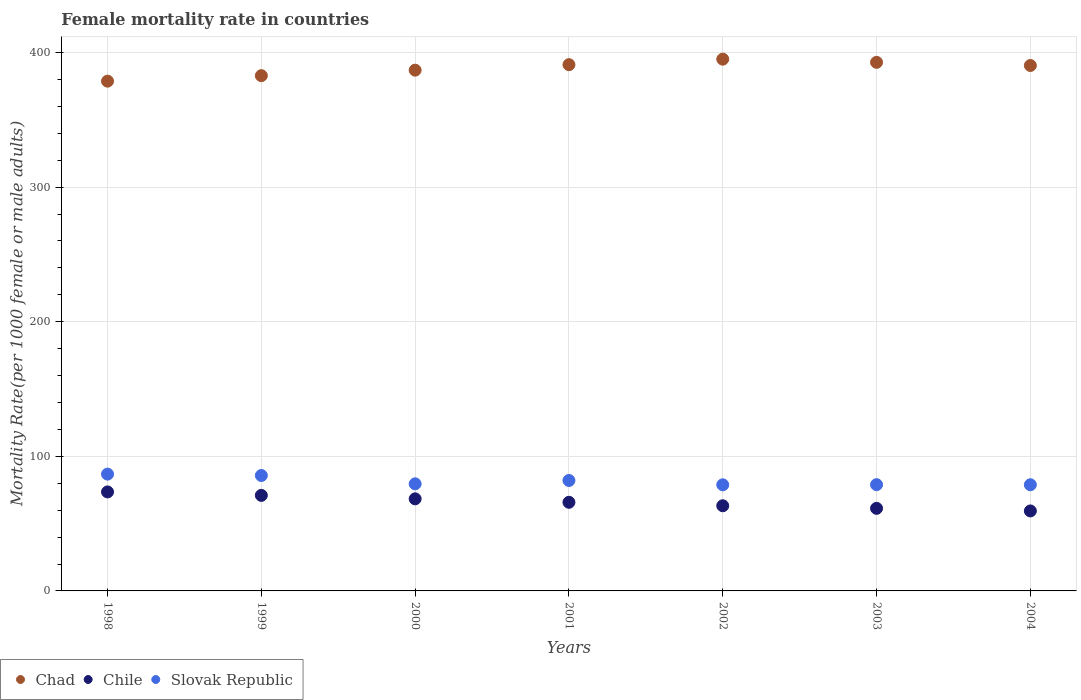How many different coloured dotlines are there?
Your response must be concise. 3. Is the number of dotlines equal to the number of legend labels?
Provide a short and direct response. Yes. What is the female mortality rate in Slovak Republic in 2001?
Offer a terse response. 82.06. Across all years, what is the maximum female mortality rate in Chad?
Make the answer very short. 395.1. Across all years, what is the minimum female mortality rate in Slovak Republic?
Offer a very short reply. 78.84. In which year was the female mortality rate in Chad minimum?
Provide a succinct answer. 1998. What is the total female mortality rate in Chad in the graph?
Your answer should be compact. 2717.83. What is the difference between the female mortality rate in Chad in 2000 and that in 2004?
Make the answer very short. -3.47. What is the difference between the female mortality rate in Chad in 2004 and the female mortality rate in Chile in 1999?
Your response must be concise. 319.42. What is the average female mortality rate in Chile per year?
Your response must be concise. 66.12. In the year 2002, what is the difference between the female mortality rate in Chile and female mortality rate in Slovak Republic?
Provide a succinct answer. -15.56. What is the ratio of the female mortality rate in Slovak Republic in 2001 to that in 2004?
Give a very brief answer. 1.04. What is the difference between the highest and the second highest female mortality rate in Chad?
Offer a very short reply. 2.35. What is the difference between the highest and the lowest female mortality rate in Slovak Republic?
Provide a short and direct response. 7.94. In how many years, is the female mortality rate in Chad greater than the average female mortality rate in Chad taken over all years?
Provide a succinct answer. 4. Is it the case that in every year, the sum of the female mortality rate in Chad and female mortality rate in Chile  is greater than the female mortality rate in Slovak Republic?
Provide a succinct answer. Yes. Does the female mortality rate in Chad monotonically increase over the years?
Keep it short and to the point. No. Is the female mortality rate in Slovak Republic strictly less than the female mortality rate in Chile over the years?
Make the answer very short. No. Does the graph contain any zero values?
Offer a terse response. No. How many legend labels are there?
Offer a very short reply. 3. How are the legend labels stacked?
Give a very brief answer. Horizontal. What is the title of the graph?
Make the answer very short. Female mortality rate in countries. Does "Turkey" appear as one of the legend labels in the graph?
Your answer should be very brief. No. What is the label or title of the X-axis?
Give a very brief answer. Years. What is the label or title of the Y-axis?
Keep it short and to the point. Mortality Rate(per 1000 female or male adults). What is the Mortality Rate(per 1000 female or male adults) in Chad in 1998?
Provide a succinct answer. 378.76. What is the Mortality Rate(per 1000 female or male adults) in Chile in 1998?
Ensure brevity in your answer.  73.56. What is the Mortality Rate(per 1000 female or male adults) in Slovak Republic in 1998?
Your response must be concise. 86.78. What is the Mortality Rate(per 1000 female or male adults) in Chad in 1999?
Your response must be concise. 382.85. What is the Mortality Rate(per 1000 female or male adults) in Chile in 1999?
Give a very brief answer. 70.99. What is the Mortality Rate(per 1000 female or male adults) in Slovak Republic in 1999?
Give a very brief answer. 85.76. What is the Mortality Rate(per 1000 female or male adults) in Chad in 2000?
Provide a succinct answer. 386.93. What is the Mortality Rate(per 1000 female or male adults) in Chile in 2000?
Give a very brief answer. 68.42. What is the Mortality Rate(per 1000 female or male adults) of Slovak Republic in 2000?
Offer a very short reply. 79.57. What is the Mortality Rate(per 1000 female or male adults) of Chad in 2001?
Give a very brief answer. 391.02. What is the Mortality Rate(per 1000 female or male adults) in Chile in 2001?
Provide a succinct answer. 65.85. What is the Mortality Rate(per 1000 female or male adults) in Slovak Republic in 2001?
Ensure brevity in your answer.  82.06. What is the Mortality Rate(per 1000 female or male adults) of Chad in 2002?
Offer a very short reply. 395.1. What is the Mortality Rate(per 1000 female or male adults) in Chile in 2002?
Provide a succinct answer. 63.28. What is the Mortality Rate(per 1000 female or male adults) of Slovak Republic in 2002?
Keep it short and to the point. 78.84. What is the Mortality Rate(per 1000 female or male adults) of Chad in 2003?
Provide a succinct answer. 392.75. What is the Mortality Rate(per 1000 female or male adults) of Chile in 2003?
Provide a short and direct response. 61.35. What is the Mortality Rate(per 1000 female or male adults) of Slovak Republic in 2003?
Give a very brief answer. 78.96. What is the Mortality Rate(per 1000 female or male adults) of Chad in 2004?
Offer a very short reply. 390.4. What is the Mortality Rate(per 1000 female or male adults) of Chile in 2004?
Give a very brief answer. 59.43. What is the Mortality Rate(per 1000 female or male adults) in Slovak Republic in 2004?
Give a very brief answer. 78.88. Across all years, what is the maximum Mortality Rate(per 1000 female or male adults) in Chad?
Your answer should be very brief. 395.1. Across all years, what is the maximum Mortality Rate(per 1000 female or male adults) in Chile?
Provide a succinct answer. 73.56. Across all years, what is the maximum Mortality Rate(per 1000 female or male adults) of Slovak Republic?
Keep it short and to the point. 86.78. Across all years, what is the minimum Mortality Rate(per 1000 female or male adults) of Chad?
Give a very brief answer. 378.76. Across all years, what is the minimum Mortality Rate(per 1000 female or male adults) of Chile?
Offer a terse response. 59.43. Across all years, what is the minimum Mortality Rate(per 1000 female or male adults) in Slovak Republic?
Your answer should be very brief. 78.84. What is the total Mortality Rate(per 1000 female or male adults) of Chad in the graph?
Your answer should be compact. 2717.83. What is the total Mortality Rate(per 1000 female or male adults) of Chile in the graph?
Give a very brief answer. 462.87. What is the total Mortality Rate(per 1000 female or male adults) of Slovak Republic in the graph?
Keep it short and to the point. 570.85. What is the difference between the Mortality Rate(per 1000 female or male adults) in Chad in 1998 and that in 1999?
Your answer should be compact. -4.08. What is the difference between the Mortality Rate(per 1000 female or male adults) of Chile in 1998 and that in 1999?
Offer a very short reply. 2.57. What is the difference between the Mortality Rate(per 1000 female or male adults) of Chad in 1998 and that in 2000?
Make the answer very short. -8.17. What is the difference between the Mortality Rate(per 1000 female or male adults) of Chile in 1998 and that in 2000?
Provide a succinct answer. 5.14. What is the difference between the Mortality Rate(per 1000 female or male adults) of Slovak Republic in 1998 and that in 2000?
Ensure brevity in your answer.  7.21. What is the difference between the Mortality Rate(per 1000 female or male adults) in Chad in 1998 and that in 2001?
Keep it short and to the point. -12.25. What is the difference between the Mortality Rate(per 1000 female or male adults) of Chile in 1998 and that in 2001?
Keep it short and to the point. 7.71. What is the difference between the Mortality Rate(per 1000 female or male adults) in Slovak Republic in 1998 and that in 2001?
Your answer should be compact. 4.71. What is the difference between the Mortality Rate(per 1000 female or male adults) of Chad in 1998 and that in 2002?
Your response must be concise. -16.34. What is the difference between the Mortality Rate(per 1000 female or male adults) in Chile in 1998 and that in 2002?
Keep it short and to the point. 10.28. What is the difference between the Mortality Rate(per 1000 female or male adults) of Slovak Republic in 1998 and that in 2002?
Keep it short and to the point. 7.94. What is the difference between the Mortality Rate(per 1000 female or male adults) in Chad in 1998 and that in 2003?
Give a very brief answer. -13.99. What is the difference between the Mortality Rate(per 1000 female or male adults) in Chile in 1998 and that in 2003?
Provide a succinct answer. 12.2. What is the difference between the Mortality Rate(per 1000 female or male adults) in Slovak Republic in 1998 and that in 2003?
Keep it short and to the point. 7.82. What is the difference between the Mortality Rate(per 1000 female or male adults) in Chad in 1998 and that in 2004?
Give a very brief answer. -11.64. What is the difference between the Mortality Rate(per 1000 female or male adults) of Chile in 1998 and that in 2004?
Give a very brief answer. 14.13. What is the difference between the Mortality Rate(per 1000 female or male adults) of Slovak Republic in 1998 and that in 2004?
Make the answer very short. 7.9. What is the difference between the Mortality Rate(per 1000 female or male adults) in Chad in 1999 and that in 2000?
Offer a very short reply. -4.08. What is the difference between the Mortality Rate(per 1000 female or male adults) in Chile in 1999 and that in 2000?
Your answer should be compact. 2.57. What is the difference between the Mortality Rate(per 1000 female or male adults) of Slovak Republic in 1999 and that in 2000?
Provide a short and direct response. 6.19. What is the difference between the Mortality Rate(per 1000 female or male adults) in Chad in 1999 and that in 2001?
Keep it short and to the point. -8.17. What is the difference between the Mortality Rate(per 1000 female or male adults) in Chile in 1999 and that in 2001?
Your answer should be very brief. 5.14. What is the difference between the Mortality Rate(per 1000 female or male adults) of Slovak Republic in 1999 and that in 2001?
Offer a very short reply. 3.69. What is the difference between the Mortality Rate(per 1000 female or male adults) in Chad in 1999 and that in 2002?
Offer a very short reply. -12.25. What is the difference between the Mortality Rate(per 1000 female or male adults) in Chile in 1999 and that in 2002?
Your response must be concise. 7.71. What is the difference between the Mortality Rate(per 1000 female or male adults) in Slovak Republic in 1999 and that in 2002?
Keep it short and to the point. 6.92. What is the difference between the Mortality Rate(per 1000 female or male adults) of Chad in 1999 and that in 2003?
Offer a very short reply. -9.9. What is the difference between the Mortality Rate(per 1000 female or male adults) of Chile in 1999 and that in 2003?
Keep it short and to the point. 9.63. What is the difference between the Mortality Rate(per 1000 female or male adults) of Slovak Republic in 1999 and that in 2003?
Offer a terse response. 6.8. What is the difference between the Mortality Rate(per 1000 female or male adults) in Chad in 1999 and that in 2004?
Ensure brevity in your answer.  -7.55. What is the difference between the Mortality Rate(per 1000 female or male adults) in Chile in 1999 and that in 2004?
Provide a succinct answer. 11.56. What is the difference between the Mortality Rate(per 1000 female or male adults) in Slovak Republic in 1999 and that in 2004?
Your response must be concise. 6.88. What is the difference between the Mortality Rate(per 1000 female or male adults) in Chad in 2000 and that in 2001?
Make the answer very short. -4.08. What is the difference between the Mortality Rate(per 1000 female or male adults) in Chile in 2000 and that in 2001?
Ensure brevity in your answer.  2.57. What is the difference between the Mortality Rate(per 1000 female or male adults) of Slovak Republic in 2000 and that in 2001?
Ensure brevity in your answer.  -2.5. What is the difference between the Mortality Rate(per 1000 female or male adults) of Chad in 2000 and that in 2002?
Your response must be concise. -8.17. What is the difference between the Mortality Rate(per 1000 female or male adults) of Chile in 2000 and that in 2002?
Offer a very short reply. 5.14. What is the difference between the Mortality Rate(per 1000 female or male adults) in Slovak Republic in 2000 and that in 2002?
Offer a very short reply. 0.73. What is the difference between the Mortality Rate(per 1000 female or male adults) in Chad in 2000 and that in 2003?
Your answer should be very brief. -5.82. What is the difference between the Mortality Rate(per 1000 female or male adults) of Chile in 2000 and that in 2003?
Ensure brevity in your answer.  7.06. What is the difference between the Mortality Rate(per 1000 female or male adults) in Slovak Republic in 2000 and that in 2003?
Ensure brevity in your answer.  0.61. What is the difference between the Mortality Rate(per 1000 female or male adults) in Chad in 2000 and that in 2004?
Give a very brief answer. -3.47. What is the difference between the Mortality Rate(per 1000 female or male adults) in Chile in 2000 and that in 2004?
Offer a very short reply. 8.99. What is the difference between the Mortality Rate(per 1000 female or male adults) in Slovak Republic in 2000 and that in 2004?
Your answer should be very brief. 0.69. What is the difference between the Mortality Rate(per 1000 female or male adults) in Chad in 2001 and that in 2002?
Your response must be concise. -4.08. What is the difference between the Mortality Rate(per 1000 female or male adults) of Chile in 2001 and that in 2002?
Your answer should be very brief. 2.57. What is the difference between the Mortality Rate(per 1000 female or male adults) of Slovak Republic in 2001 and that in 2002?
Provide a succinct answer. 3.23. What is the difference between the Mortality Rate(per 1000 female or male adults) in Chad in 2001 and that in 2003?
Ensure brevity in your answer.  -1.74. What is the difference between the Mortality Rate(per 1000 female or male adults) in Chile in 2001 and that in 2003?
Your response must be concise. 4.49. What is the difference between the Mortality Rate(per 1000 female or male adults) in Slovak Republic in 2001 and that in 2003?
Keep it short and to the point. 3.11. What is the difference between the Mortality Rate(per 1000 female or male adults) of Chad in 2001 and that in 2004?
Your response must be concise. 0.61. What is the difference between the Mortality Rate(per 1000 female or male adults) of Chile in 2001 and that in 2004?
Provide a succinct answer. 6.42. What is the difference between the Mortality Rate(per 1000 female or male adults) in Slovak Republic in 2001 and that in 2004?
Make the answer very short. 3.19. What is the difference between the Mortality Rate(per 1000 female or male adults) in Chad in 2002 and that in 2003?
Provide a short and direct response. 2.35. What is the difference between the Mortality Rate(per 1000 female or male adults) of Chile in 2002 and that in 2003?
Offer a very short reply. 1.92. What is the difference between the Mortality Rate(per 1000 female or male adults) in Slovak Republic in 2002 and that in 2003?
Keep it short and to the point. -0.12. What is the difference between the Mortality Rate(per 1000 female or male adults) of Chad in 2002 and that in 2004?
Your response must be concise. 4.7. What is the difference between the Mortality Rate(per 1000 female or male adults) of Chile in 2002 and that in 2004?
Keep it short and to the point. 3.85. What is the difference between the Mortality Rate(per 1000 female or male adults) of Slovak Republic in 2002 and that in 2004?
Provide a succinct answer. -0.04. What is the difference between the Mortality Rate(per 1000 female or male adults) in Chad in 2003 and that in 2004?
Make the answer very short. 2.35. What is the difference between the Mortality Rate(per 1000 female or male adults) in Chile in 2003 and that in 2004?
Offer a terse response. 1.93. What is the difference between the Mortality Rate(per 1000 female or male adults) of Slovak Republic in 2003 and that in 2004?
Give a very brief answer. 0.08. What is the difference between the Mortality Rate(per 1000 female or male adults) of Chad in 1998 and the Mortality Rate(per 1000 female or male adults) of Chile in 1999?
Keep it short and to the point. 307.78. What is the difference between the Mortality Rate(per 1000 female or male adults) of Chad in 1998 and the Mortality Rate(per 1000 female or male adults) of Slovak Republic in 1999?
Keep it short and to the point. 293.01. What is the difference between the Mortality Rate(per 1000 female or male adults) in Chile in 1998 and the Mortality Rate(per 1000 female or male adults) in Slovak Republic in 1999?
Your answer should be very brief. -12.2. What is the difference between the Mortality Rate(per 1000 female or male adults) of Chad in 1998 and the Mortality Rate(per 1000 female or male adults) of Chile in 2000?
Make the answer very short. 310.35. What is the difference between the Mortality Rate(per 1000 female or male adults) in Chad in 1998 and the Mortality Rate(per 1000 female or male adults) in Slovak Republic in 2000?
Keep it short and to the point. 299.2. What is the difference between the Mortality Rate(per 1000 female or male adults) of Chile in 1998 and the Mortality Rate(per 1000 female or male adults) of Slovak Republic in 2000?
Provide a short and direct response. -6.01. What is the difference between the Mortality Rate(per 1000 female or male adults) of Chad in 1998 and the Mortality Rate(per 1000 female or male adults) of Chile in 2001?
Provide a succinct answer. 312.92. What is the difference between the Mortality Rate(per 1000 female or male adults) of Chad in 1998 and the Mortality Rate(per 1000 female or male adults) of Slovak Republic in 2001?
Your answer should be compact. 296.7. What is the difference between the Mortality Rate(per 1000 female or male adults) in Chile in 1998 and the Mortality Rate(per 1000 female or male adults) in Slovak Republic in 2001?
Offer a terse response. -8.51. What is the difference between the Mortality Rate(per 1000 female or male adults) of Chad in 1998 and the Mortality Rate(per 1000 female or male adults) of Chile in 2002?
Your answer should be very brief. 315.49. What is the difference between the Mortality Rate(per 1000 female or male adults) of Chad in 1998 and the Mortality Rate(per 1000 female or male adults) of Slovak Republic in 2002?
Keep it short and to the point. 299.93. What is the difference between the Mortality Rate(per 1000 female or male adults) of Chile in 1998 and the Mortality Rate(per 1000 female or male adults) of Slovak Republic in 2002?
Keep it short and to the point. -5.28. What is the difference between the Mortality Rate(per 1000 female or male adults) of Chad in 1998 and the Mortality Rate(per 1000 female or male adults) of Chile in 2003?
Offer a terse response. 317.41. What is the difference between the Mortality Rate(per 1000 female or male adults) of Chad in 1998 and the Mortality Rate(per 1000 female or male adults) of Slovak Republic in 2003?
Your answer should be compact. 299.81. What is the difference between the Mortality Rate(per 1000 female or male adults) of Chile in 1998 and the Mortality Rate(per 1000 female or male adults) of Slovak Republic in 2003?
Offer a very short reply. -5.4. What is the difference between the Mortality Rate(per 1000 female or male adults) in Chad in 1998 and the Mortality Rate(per 1000 female or male adults) in Chile in 2004?
Give a very brief answer. 319.34. What is the difference between the Mortality Rate(per 1000 female or male adults) in Chad in 1998 and the Mortality Rate(per 1000 female or male adults) in Slovak Republic in 2004?
Offer a terse response. 299.89. What is the difference between the Mortality Rate(per 1000 female or male adults) in Chile in 1998 and the Mortality Rate(per 1000 female or male adults) in Slovak Republic in 2004?
Provide a short and direct response. -5.32. What is the difference between the Mortality Rate(per 1000 female or male adults) of Chad in 1999 and the Mortality Rate(per 1000 female or male adults) of Chile in 2000?
Offer a very short reply. 314.43. What is the difference between the Mortality Rate(per 1000 female or male adults) in Chad in 1999 and the Mortality Rate(per 1000 female or male adults) in Slovak Republic in 2000?
Provide a short and direct response. 303.28. What is the difference between the Mortality Rate(per 1000 female or male adults) of Chile in 1999 and the Mortality Rate(per 1000 female or male adults) of Slovak Republic in 2000?
Make the answer very short. -8.58. What is the difference between the Mortality Rate(per 1000 female or male adults) of Chad in 1999 and the Mortality Rate(per 1000 female or male adults) of Chile in 2001?
Provide a short and direct response. 317. What is the difference between the Mortality Rate(per 1000 female or male adults) in Chad in 1999 and the Mortality Rate(per 1000 female or male adults) in Slovak Republic in 2001?
Your answer should be very brief. 300.78. What is the difference between the Mortality Rate(per 1000 female or male adults) of Chile in 1999 and the Mortality Rate(per 1000 female or male adults) of Slovak Republic in 2001?
Your answer should be compact. -11.08. What is the difference between the Mortality Rate(per 1000 female or male adults) in Chad in 1999 and the Mortality Rate(per 1000 female or male adults) in Chile in 2002?
Your answer should be compact. 319.57. What is the difference between the Mortality Rate(per 1000 female or male adults) of Chad in 1999 and the Mortality Rate(per 1000 female or male adults) of Slovak Republic in 2002?
Provide a short and direct response. 304.01. What is the difference between the Mortality Rate(per 1000 female or male adults) of Chile in 1999 and the Mortality Rate(per 1000 female or male adults) of Slovak Republic in 2002?
Provide a short and direct response. -7.85. What is the difference between the Mortality Rate(per 1000 female or male adults) of Chad in 1999 and the Mortality Rate(per 1000 female or male adults) of Chile in 2003?
Ensure brevity in your answer.  321.5. What is the difference between the Mortality Rate(per 1000 female or male adults) in Chad in 1999 and the Mortality Rate(per 1000 female or male adults) in Slovak Republic in 2003?
Ensure brevity in your answer.  303.89. What is the difference between the Mortality Rate(per 1000 female or male adults) in Chile in 1999 and the Mortality Rate(per 1000 female or male adults) in Slovak Republic in 2003?
Provide a succinct answer. -7.97. What is the difference between the Mortality Rate(per 1000 female or male adults) in Chad in 1999 and the Mortality Rate(per 1000 female or male adults) in Chile in 2004?
Provide a short and direct response. 323.42. What is the difference between the Mortality Rate(per 1000 female or male adults) in Chad in 1999 and the Mortality Rate(per 1000 female or male adults) in Slovak Republic in 2004?
Offer a very short reply. 303.97. What is the difference between the Mortality Rate(per 1000 female or male adults) in Chile in 1999 and the Mortality Rate(per 1000 female or male adults) in Slovak Republic in 2004?
Keep it short and to the point. -7.89. What is the difference between the Mortality Rate(per 1000 female or male adults) of Chad in 2000 and the Mortality Rate(per 1000 female or male adults) of Chile in 2001?
Your answer should be very brief. 321.09. What is the difference between the Mortality Rate(per 1000 female or male adults) of Chad in 2000 and the Mortality Rate(per 1000 female or male adults) of Slovak Republic in 2001?
Ensure brevity in your answer.  304.87. What is the difference between the Mortality Rate(per 1000 female or male adults) of Chile in 2000 and the Mortality Rate(per 1000 female or male adults) of Slovak Republic in 2001?
Keep it short and to the point. -13.65. What is the difference between the Mortality Rate(per 1000 female or male adults) in Chad in 2000 and the Mortality Rate(per 1000 female or male adults) in Chile in 2002?
Your response must be concise. 323.66. What is the difference between the Mortality Rate(per 1000 female or male adults) in Chad in 2000 and the Mortality Rate(per 1000 female or male adults) in Slovak Republic in 2002?
Provide a short and direct response. 308.09. What is the difference between the Mortality Rate(per 1000 female or male adults) of Chile in 2000 and the Mortality Rate(per 1000 female or male adults) of Slovak Republic in 2002?
Offer a terse response. -10.42. What is the difference between the Mortality Rate(per 1000 female or male adults) in Chad in 2000 and the Mortality Rate(per 1000 female or male adults) in Chile in 2003?
Offer a very short reply. 325.58. What is the difference between the Mortality Rate(per 1000 female or male adults) of Chad in 2000 and the Mortality Rate(per 1000 female or male adults) of Slovak Republic in 2003?
Give a very brief answer. 307.98. What is the difference between the Mortality Rate(per 1000 female or male adults) of Chile in 2000 and the Mortality Rate(per 1000 female or male adults) of Slovak Republic in 2003?
Ensure brevity in your answer.  -10.54. What is the difference between the Mortality Rate(per 1000 female or male adults) of Chad in 2000 and the Mortality Rate(per 1000 female or male adults) of Chile in 2004?
Provide a short and direct response. 327.51. What is the difference between the Mortality Rate(per 1000 female or male adults) in Chad in 2000 and the Mortality Rate(per 1000 female or male adults) in Slovak Republic in 2004?
Give a very brief answer. 308.06. What is the difference between the Mortality Rate(per 1000 female or male adults) of Chile in 2000 and the Mortality Rate(per 1000 female or male adults) of Slovak Republic in 2004?
Your answer should be compact. -10.46. What is the difference between the Mortality Rate(per 1000 female or male adults) of Chad in 2001 and the Mortality Rate(per 1000 female or male adults) of Chile in 2002?
Make the answer very short. 327.74. What is the difference between the Mortality Rate(per 1000 female or male adults) of Chad in 2001 and the Mortality Rate(per 1000 female or male adults) of Slovak Republic in 2002?
Provide a succinct answer. 312.18. What is the difference between the Mortality Rate(per 1000 female or male adults) of Chile in 2001 and the Mortality Rate(per 1000 female or male adults) of Slovak Republic in 2002?
Offer a terse response. -12.99. What is the difference between the Mortality Rate(per 1000 female or male adults) in Chad in 2001 and the Mortality Rate(per 1000 female or male adults) in Chile in 2003?
Provide a short and direct response. 329.67. What is the difference between the Mortality Rate(per 1000 female or male adults) in Chad in 2001 and the Mortality Rate(per 1000 female or male adults) in Slovak Republic in 2003?
Offer a terse response. 312.06. What is the difference between the Mortality Rate(per 1000 female or male adults) of Chile in 2001 and the Mortality Rate(per 1000 female or male adults) of Slovak Republic in 2003?
Your answer should be very brief. -13.11. What is the difference between the Mortality Rate(per 1000 female or male adults) of Chad in 2001 and the Mortality Rate(per 1000 female or male adults) of Chile in 2004?
Make the answer very short. 331.59. What is the difference between the Mortality Rate(per 1000 female or male adults) of Chad in 2001 and the Mortality Rate(per 1000 female or male adults) of Slovak Republic in 2004?
Provide a short and direct response. 312.14. What is the difference between the Mortality Rate(per 1000 female or male adults) of Chile in 2001 and the Mortality Rate(per 1000 female or male adults) of Slovak Republic in 2004?
Keep it short and to the point. -13.03. What is the difference between the Mortality Rate(per 1000 female or male adults) in Chad in 2002 and the Mortality Rate(per 1000 female or male adults) in Chile in 2003?
Provide a short and direct response. 333.75. What is the difference between the Mortality Rate(per 1000 female or male adults) in Chad in 2002 and the Mortality Rate(per 1000 female or male adults) in Slovak Republic in 2003?
Keep it short and to the point. 316.15. What is the difference between the Mortality Rate(per 1000 female or male adults) of Chile in 2002 and the Mortality Rate(per 1000 female or male adults) of Slovak Republic in 2003?
Keep it short and to the point. -15.68. What is the difference between the Mortality Rate(per 1000 female or male adults) in Chad in 2002 and the Mortality Rate(per 1000 female or male adults) in Chile in 2004?
Keep it short and to the point. 335.68. What is the difference between the Mortality Rate(per 1000 female or male adults) of Chad in 2002 and the Mortality Rate(per 1000 female or male adults) of Slovak Republic in 2004?
Your response must be concise. 316.23. What is the difference between the Mortality Rate(per 1000 female or male adults) of Chile in 2002 and the Mortality Rate(per 1000 female or male adults) of Slovak Republic in 2004?
Provide a short and direct response. -15.6. What is the difference between the Mortality Rate(per 1000 female or male adults) in Chad in 2003 and the Mortality Rate(per 1000 female or male adults) in Chile in 2004?
Offer a very short reply. 333.32. What is the difference between the Mortality Rate(per 1000 female or male adults) in Chad in 2003 and the Mortality Rate(per 1000 female or male adults) in Slovak Republic in 2004?
Ensure brevity in your answer.  313.88. What is the difference between the Mortality Rate(per 1000 female or male adults) of Chile in 2003 and the Mortality Rate(per 1000 female or male adults) of Slovak Republic in 2004?
Provide a short and direct response. -17.52. What is the average Mortality Rate(per 1000 female or male adults) in Chad per year?
Give a very brief answer. 388.26. What is the average Mortality Rate(per 1000 female or male adults) of Chile per year?
Make the answer very short. 66.12. What is the average Mortality Rate(per 1000 female or male adults) in Slovak Republic per year?
Offer a terse response. 81.55. In the year 1998, what is the difference between the Mortality Rate(per 1000 female or male adults) in Chad and Mortality Rate(per 1000 female or male adults) in Chile?
Offer a terse response. 305.21. In the year 1998, what is the difference between the Mortality Rate(per 1000 female or male adults) in Chad and Mortality Rate(per 1000 female or male adults) in Slovak Republic?
Your response must be concise. 291.99. In the year 1998, what is the difference between the Mortality Rate(per 1000 female or male adults) of Chile and Mortality Rate(per 1000 female or male adults) of Slovak Republic?
Provide a succinct answer. -13.22. In the year 1999, what is the difference between the Mortality Rate(per 1000 female or male adults) of Chad and Mortality Rate(per 1000 female or male adults) of Chile?
Your answer should be very brief. 311.86. In the year 1999, what is the difference between the Mortality Rate(per 1000 female or male adults) of Chad and Mortality Rate(per 1000 female or male adults) of Slovak Republic?
Make the answer very short. 297.09. In the year 1999, what is the difference between the Mortality Rate(per 1000 female or male adults) of Chile and Mortality Rate(per 1000 female or male adults) of Slovak Republic?
Offer a terse response. -14.77. In the year 2000, what is the difference between the Mortality Rate(per 1000 female or male adults) in Chad and Mortality Rate(per 1000 female or male adults) in Chile?
Your answer should be compact. 318.52. In the year 2000, what is the difference between the Mortality Rate(per 1000 female or male adults) in Chad and Mortality Rate(per 1000 female or male adults) in Slovak Republic?
Offer a very short reply. 307.37. In the year 2000, what is the difference between the Mortality Rate(per 1000 female or male adults) in Chile and Mortality Rate(per 1000 female or male adults) in Slovak Republic?
Provide a succinct answer. -11.15. In the year 2001, what is the difference between the Mortality Rate(per 1000 female or male adults) of Chad and Mortality Rate(per 1000 female or male adults) of Chile?
Keep it short and to the point. 325.17. In the year 2001, what is the difference between the Mortality Rate(per 1000 female or male adults) of Chad and Mortality Rate(per 1000 female or male adults) of Slovak Republic?
Your response must be concise. 308.95. In the year 2001, what is the difference between the Mortality Rate(per 1000 female or male adults) of Chile and Mortality Rate(per 1000 female or male adults) of Slovak Republic?
Your answer should be very brief. -16.22. In the year 2002, what is the difference between the Mortality Rate(per 1000 female or male adults) of Chad and Mortality Rate(per 1000 female or male adults) of Chile?
Offer a terse response. 331.83. In the year 2002, what is the difference between the Mortality Rate(per 1000 female or male adults) in Chad and Mortality Rate(per 1000 female or male adults) in Slovak Republic?
Your answer should be very brief. 316.26. In the year 2002, what is the difference between the Mortality Rate(per 1000 female or male adults) of Chile and Mortality Rate(per 1000 female or male adults) of Slovak Republic?
Provide a succinct answer. -15.56. In the year 2003, what is the difference between the Mortality Rate(per 1000 female or male adults) in Chad and Mortality Rate(per 1000 female or male adults) in Chile?
Your answer should be compact. 331.4. In the year 2003, what is the difference between the Mortality Rate(per 1000 female or male adults) in Chad and Mortality Rate(per 1000 female or male adults) in Slovak Republic?
Your response must be concise. 313.8. In the year 2003, what is the difference between the Mortality Rate(per 1000 female or male adults) of Chile and Mortality Rate(per 1000 female or male adults) of Slovak Republic?
Your answer should be very brief. -17.6. In the year 2004, what is the difference between the Mortality Rate(per 1000 female or male adults) in Chad and Mortality Rate(per 1000 female or male adults) in Chile?
Your answer should be very brief. 330.98. In the year 2004, what is the difference between the Mortality Rate(per 1000 female or male adults) in Chad and Mortality Rate(per 1000 female or male adults) in Slovak Republic?
Keep it short and to the point. 311.53. In the year 2004, what is the difference between the Mortality Rate(per 1000 female or male adults) of Chile and Mortality Rate(per 1000 female or male adults) of Slovak Republic?
Make the answer very short. -19.45. What is the ratio of the Mortality Rate(per 1000 female or male adults) in Chad in 1998 to that in 1999?
Give a very brief answer. 0.99. What is the ratio of the Mortality Rate(per 1000 female or male adults) of Chile in 1998 to that in 1999?
Ensure brevity in your answer.  1.04. What is the ratio of the Mortality Rate(per 1000 female or male adults) of Slovak Republic in 1998 to that in 1999?
Your response must be concise. 1.01. What is the ratio of the Mortality Rate(per 1000 female or male adults) in Chad in 1998 to that in 2000?
Your answer should be very brief. 0.98. What is the ratio of the Mortality Rate(per 1000 female or male adults) of Chile in 1998 to that in 2000?
Your answer should be very brief. 1.08. What is the ratio of the Mortality Rate(per 1000 female or male adults) in Slovak Republic in 1998 to that in 2000?
Your response must be concise. 1.09. What is the ratio of the Mortality Rate(per 1000 female or male adults) in Chad in 1998 to that in 2001?
Provide a succinct answer. 0.97. What is the ratio of the Mortality Rate(per 1000 female or male adults) of Chile in 1998 to that in 2001?
Give a very brief answer. 1.12. What is the ratio of the Mortality Rate(per 1000 female or male adults) in Slovak Republic in 1998 to that in 2001?
Make the answer very short. 1.06. What is the ratio of the Mortality Rate(per 1000 female or male adults) of Chad in 1998 to that in 2002?
Ensure brevity in your answer.  0.96. What is the ratio of the Mortality Rate(per 1000 female or male adults) of Chile in 1998 to that in 2002?
Make the answer very short. 1.16. What is the ratio of the Mortality Rate(per 1000 female or male adults) of Slovak Republic in 1998 to that in 2002?
Provide a succinct answer. 1.1. What is the ratio of the Mortality Rate(per 1000 female or male adults) in Chad in 1998 to that in 2003?
Make the answer very short. 0.96. What is the ratio of the Mortality Rate(per 1000 female or male adults) in Chile in 1998 to that in 2003?
Provide a short and direct response. 1.2. What is the ratio of the Mortality Rate(per 1000 female or male adults) in Slovak Republic in 1998 to that in 2003?
Ensure brevity in your answer.  1.1. What is the ratio of the Mortality Rate(per 1000 female or male adults) in Chad in 1998 to that in 2004?
Offer a very short reply. 0.97. What is the ratio of the Mortality Rate(per 1000 female or male adults) in Chile in 1998 to that in 2004?
Provide a succinct answer. 1.24. What is the ratio of the Mortality Rate(per 1000 female or male adults) in Slovak Republic in 1998 to that in 2004?
Your answer should be compact. 1.1. What is the ratio of the Mortality Rate(per 1000 female or male adults) of Chad in 1999 to that in 2000?
Give a very brief answer. 0.99. What is the ratio of the Mortality Rate(per 1000 female or male adults) in Chile in 1999 to that in 2000?
Provide a succinct answer. 1.04. What is the ratio of the Mortality Rate(per 1000 female or male adults) of Slovak Republic in 1999 to that in 2000?
Give a very brief answer. 1.08. What is the ratio of the Mortality Rate(per 1000 female or male adults) of Chad in 1999 to that in 2001?
Provide a succinct answer. 0.98. What is the ratio of the Mortality Rate(per 1000 female or male adults) in Chile in 1999 to that in 2001?
Your answer should be compact. 1.08. What is the ratio of the Mortality Rate(per 1000 female or male adults) in Slovak Republic in 1999 to that in 2001?
Offer a very short reply. 1.04. What is the ratio of the Mortality Rate(per 1000 female or male adults) of Chile in 1999 to that in 2002?
Keep it short and to the point. 1.12. What is the ratio of the Mortality Rate(per 1000 female or male adults) in Slovak Republic in 1999 to that in 2002?
Keep it short and to the point. 1.09. What is the ratio of the Mortality Rate(per 1000 female or male adults) in Chad in 1999 to that in 2003?
Provide a succinct answer. 0.97. What is the ratio of the Mortality Rate(per 1000 female or male adults) of Chile in 1999 to that in 2003?
Provide a short and direct response. 1.16. What is the ratio of the Mortality Rate(per 1000 female or male adults) of Slovak Republic in 1999 to that in 2003?
Your response must be concise. 1.09. What is the ratio of the Mortality Rate(per 1000 female or male adults) in Chad in 1999 to that in 2004?
Offer a very short reply. 0.98. What is the ratio of the Mortality Rate(per 1000 female or male adults) in Chile in 1999 to that in 2004?
Your response must be concise. 1.19. What is the ratio of the Mortality Rate(per 1000 female or male adults) in Slovak Republic in 1999 to that in 2004?
Your answer should be very brief. 1.09. What is the ratio of the Mortality Rate(per 1000 female or male adults) in Chile in 2000 to that in 2001?
Your answer should be very brief. 1.04. What is the ratio of the Mortality Rate(per 1000 female or male adults) in Slovak Republic in 2000 to that in 2001?
Your response must be concise. 0.97. What is the ratio of the Mortality Rate(per 1000 female or male adults) of Chad in 2000 to that in 2002?
Your answer should be compact. 0.98. What is the ratio of the Mortality Rate(per 1000 female or male adults) of Chile in 2000 to that in 2002?
Your answer should be compact. 1.08. What is the ratio of the Mortality Rate(per 1000 female or male adults) in Slovak Republic in 2000 to that in 2002?
Make the answer very short. 1.01. What is the ratio of the Mortality Rate(per 1000 female or male adults) of Chad in 2000 to that in 2003?
Ensure brevity in your answer.  0.99. What is the ratio of the Mortality Rate(per 1000 female or male adults) of Chile in 2000 to that in 2003?
Provide a short and direct response. 1.12. What is the ratio of the Mortality Rate(per 1000 female or male adults) in Slovak Republic in 2000 to that in 2003?
Keep it short and to the point. 1.01. What is the ratio of the Mortality Rate(per 1000 female or male adults) of Chad in 2000 to that in 2004?
Keep it short and to the point. 0.99. What is the ratio of the Mortality Rate(per 1000 female or male adults) of Chile in 2000 to that in 2004?
Your response must be concise. 1.15. What is the ratio of the Mortality Rate(per 1000 female or male adults) in Slovak Republic in 2000 to that in 2004?
Your answer should be very brief. 1.01. What is the ratio of the Mortality Rate(per 1000 female or male adults) in Chile in 2001 to that in 2002?
Keep it short and to the point. 1.04. What is the ratio of the Mortality Rate(per 1000 female or male adults) of Slovak Republic in 2001 to that in 2002?
Offer a very short reply. 1.04. What is the ratio of the Mortality Rate(per 1000 female or male adults) in Chile in 2001 to that in 2003?
Offer a very short reply. 1.07. What is the ratio of the Mortality Rate(per 1000 female or male adults) in Slovak Republic in 2001 to that in 2003?
Keep it short and to the point. 1.04. What is the ratio of the Mortality Rate(per 1000 female or male adults) in Chad in 2001 to that in 2004?
Give a very brief answer. 1. What is the ratio of the Mortality Rate(per 1000 female or male adults) in Chile in 2001 to that in 2004?
Provide a short and direct response. 1.11. What is the ratio of the Mortality Rate(per 1000 female or male adults) of Slovak Republic in 2001 to that in 2004?
Give a very brief answer. 1.04. What is the ratio of the Mortality Rate(per 1000 female or male adults) in Chile in 2002 to that in 2003?
Keep it short and to the point. 1.03. What is the ratio of the Mortality Rate(per 1000 female or male adults) in Chile in 2002 to that in 2004?
Ensure brevity in your answer.  1.06. What is the ratio of the Mortality Rate(per 1000 female or male adults) of Slovak Republic in 2002 to that in 2004?
Your answer should be compact. 1. What is the ratio of the Mortality Rate(per 1000 female or male adults) of Chad in 2003 to that in 2004?
Make the answer very short. 1.01. What is the ratio of the Mortality Rate(per 1000 female or male adults) of Chile in 2003 to that in 2004?
Keep it short and to the point. 1.03. What is the difference between the highest and the second highest Mortality Rate(per 1000 female or male adults) of Chad?
Your answer should be compact. 2.35. What is the difference between the highest and the second highest Mortality Rate(per 1000 female or male adults) of Chile?
Your answer should be compact. 2.57. What is the difference between the highest and the lowest Mortality Rate(per 1000 female or male adults) in Chad?
Offer a very short reply. 16.34. What is the difference between the highest and the lowest Mortality Rate(per 1000 female or male adults) in Chile?
Your answer should be very brief. 14.13. What is the difference between the highest and the lowest Mortality Rate(per 1000 female or male adults) of Slovak Republic?
Make the answer very short. 7.94. 